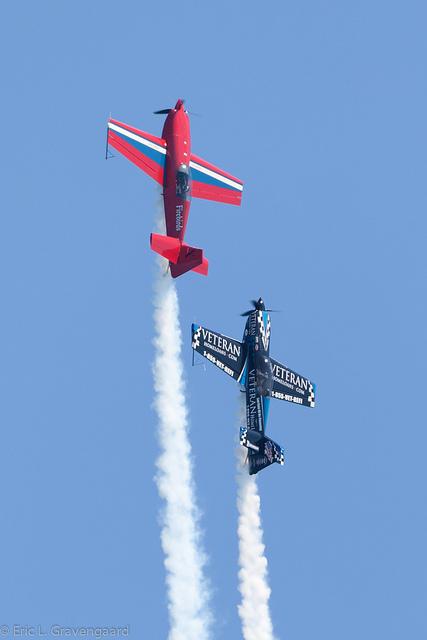Do these planes look like passenger airliners?
Quick response, please. No. Are there trails behind the planes?
Concise answer only. Yes. How many planes are there?
Short answer required. 2. 